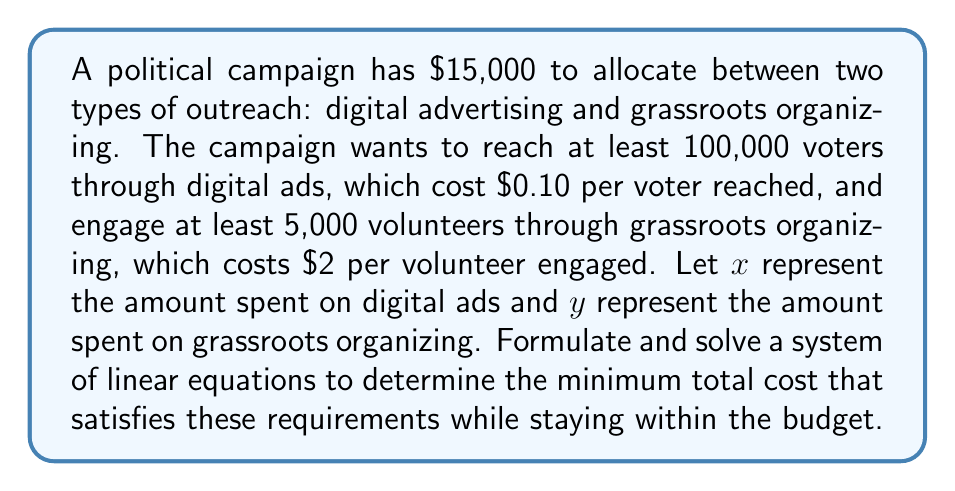Could you help me with this problem? 1. Set up the equations:
   - Budget constraint: $x + y = 15000$
   - Digital ad requirement: $\frac{x}{0.10} \geq 100000$, simplifies to $x \geq 10000$
   - Grassroots organizing requirement: $\frac{y}{2} \geq 5000$, simplifies to $y \geq 10000$

2. From the digital ad and grassroots requirements:
   $x = 10000$ and $y = 10000$

3. Check if this satisfies the budget constraint:
   $10000 + 10000 = 20000$, which exceeds the $15000 budget

4. Since we can't meet both requirements fully within the budget, we need to find the minimum that satisfies the constraints:
   $x + y = 15000$
   $x \geq 10000$
   $y \geq 10000$

5. The solution that minimizes cost while meeting the constraints is:
   $x = 10000$ (minimum for digital ads)
   $y = 5000$ (remaining budget for grassroots organizing)

6. Verify:
   $10000 + 5000 = 15000$ (meets budget constraint)
   $\frac{10000}{0.10} = 100000$ voters reached (meets digital ad requirement)
   $\frac{5000}{2} = 2500$ volunteers engaged (doesn't meet grassroots requirement, but it's the best possible within the budget)
Answer: $x = 10000, y = 5000$ 